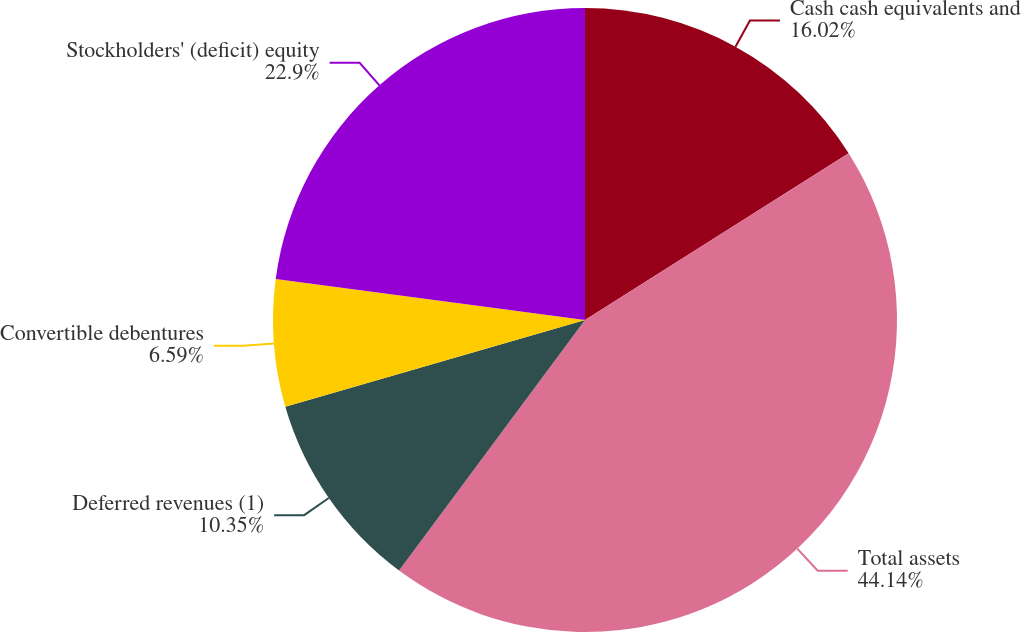<chart> <loc_0><loc_0><loc_500><loc_500><pie_chart><fcel>Cash cash equivalents and<fcel>Total assets<fcel>Deferred revenues (1)<fcel>Convertible debentures<fcel>Stockholders' (deficit) equity<nl><fcel>16.02%<fcel>44.14%<fcel>10.35%<fcel>6.59%<fcel>22.9%<nl></chart> 